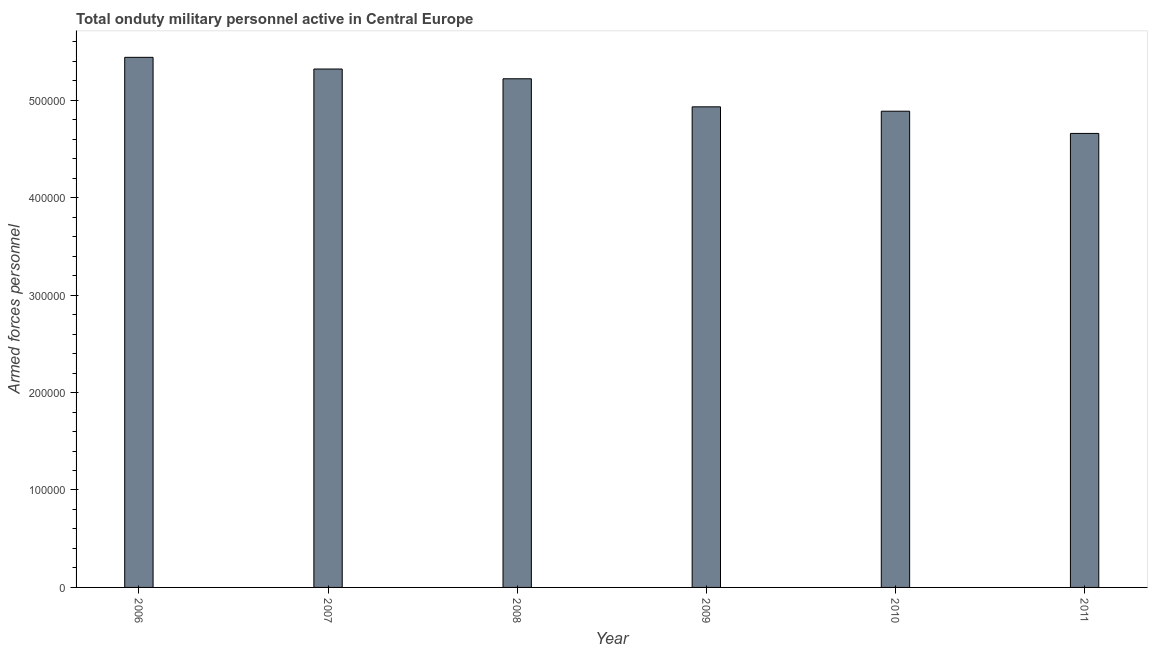Does the graph contain grids?
Make the answer very short. No. What is the title of the graph?
Keep it short and to the point. Total onduty military personnel active in Central Europe. What is the label or title of the X-axis?
Ensure brevity in your answer.  Year. What is the label or title of the Y-axis?
Give a very brief answer. Armed forces personnel. What is the number of armed forces personnel in 2008?
Provide a short and direct response. 5.22e+05. Across all years, what is the maximum number of armed forces personnel?
Ensure brevity in your answer.  5.44e+05. Across all years, what is the minimum number of armed forces personnel?
Your response must be concise. 4.66e+05. In which year was the number of armed forces personnel minimum?
Give a very brief answer. 2011. What is the sum of the number of armed forces personnel?
Your answer should be compact. 3.05e+06. What is the difference between the number of armed forces personnel in 2007 and 2010?
Provide a short and direct response. 4.33e+04. What is the average number of armed forces personnel per year?
Offer a very short reply. 5.08e+05. What is the median number of armed forces personnel?
Provide a succinct answer. 5.08e+05. In how many years, is the number of armed forces personnel greater than 80000 ?
Give a very brief answer. 6. Do a majority of the years between 2009 and 2006 (inclusive) have number of armed forces personnel greater than 360000 ?
Offer a very short reply. Yes. What is the ratio of the number of armed forces personnel in 2009 to that in 2010?
Make the answer very short. 1.01. Is the number of armed forces personnel in 2009 less than that in 2010?
Provide a short and direct response. No. What is the difference between the highest and the second highest number of armed forces personnel?
Your answer should be very brief. 1.20e+04. What is the difference between the highest and the lowest number of armed forces personnel?
Your response must be concise. 7.81e+04. How many years are there in the graph?
Ensure brevity in your answer.  6. What is the Armed forces personnel in 2006?
Provide a succinct answer. 5.44e+05. What is the Armed forces personnel in 2007?
Make the answer very short. 5.32e+05. What is the Armed forces personnel of 2008?
Give a very brief answer. 5.22e+05. What is the Armed forces personnel of 2009?
Your response must be concise. 4.93e+05. What is the Armed forces personnel of 2010?
Keep it short and to the point. 4.89e+05. What is the Armed forces personnel of 2011?
Provide a succinct answer. 4.66e+05. What is the difference between the Armed forces personnel in 2006 and 2007?
Provide a succinct answer. 1.20e+04. What is the difference between the Armed forces personnel in 2006 and 2008?
Provide a short and direct response. 2.20e+04. What is the difference between the Armed forces personnel in 2006 and 2009?
Your answer should be compact. 5.08e+04. What is the difference between the Armed forces personnel in 2006 and 2010?
Make the answer very short. 5.53e+04. What is the difference between the Armed forces personnel in 2006 and 2011?
Your response must be concise. 7.81e+04. What is the difference between the Armed forces personnel in 2007 and 2008?
Your response must be concise. 10000. What is the difference between the Armed forces personnel in 2007 and 2009?
Provide a succinct answer. 3.88e+04. What is the difference between the Armed forces personnel in 2007 and 2010?
Provide a succinct answer. 4.33e+04. What is the difference between the Armed forces personnel in 2007 and 2011?
Keep it short and to the point. 6.61e+04. What is the difference between the Armed forces personnel in 2008 and 2009?
Your answer should be very brief. 2.88e+04. What is the difference between the Armed forces personnel in 2008 and 2010?
Your response must be concise. 3.33e+04. What is the difference between the Armed forces personnel in 2008 and 2011?
Provide a succinct answer. 5.61e+04. What is the difference between the Armed forces personnel in 2009 and 2010?
Provide a succinct answer. 4481. What is the difference between the Armed forces personnel in 2009 and 2011?
Make the answer very short. 2.73e+04. What is the difference between the Armed forces personnel in 2010 and 2011?
Your answer should be compact. 2.28e+04. What is the ratio of the Armed forces personnel in 2006 to that in 2008?
Offer a very short reply. 1.04. What is the ratio of the Armed forces personnel in 2006 to that in 2009?
Your response must be concise. 1.1. What is the ratio of the Armed forces personnel in 2006 to that in 2010?
Keep it short and to the point. 1.11. What is the ratio of the Armed forces personnel in 2006 to that in 2011?
Ensure brevity in your answer.  1.17. What is the ratio of the Armed forces personnel in 2007 to that in 2008?
Keep it short and to the point. 1.02. What is the ratio of the Armed forces personnel in 2007 to that in 2009?
Give a very brief answer. 1.08. What is the ratio of the Armed forces personnel in 2007 to that in 2010?
Offer a terse response. 1.09. What is the ratio of the Armed forces personnel in 2007 to that in 2011?
Ensure brevity in your answer.  1.14. What is the ratio of the Armed forces personnel in 2008 to that in 2009?
Keep it short and to the point. 1.06. What is the ratio of the Armed forces personnel in 2008 to that in 2010?
Give a very brief answer. 1.07. What is the ratio of the Armed forces personnel in 2008 to that in 2011?
Give a very brief answer. 1.12. What is the ratio of the Armed forces personnel in 2009 to that in 2011?
Your answer should be very brief. 1.06. What is the ratio of the Armed forces personnel in 2010 to that in 2011?
Your answer should be very brief. 1.05. 